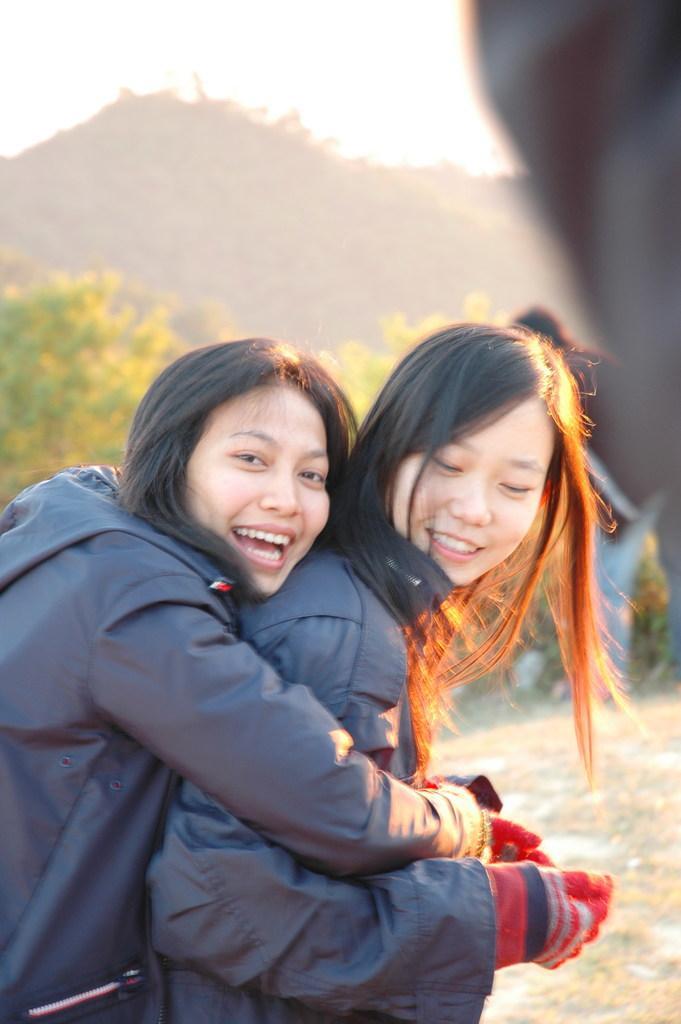How would you summarize this image in a sentence or two? In this image there is the sky, there are mountains, there are plants, there are persons standing, there is an object truncated towards the right of the image, there is a person truncated towards the left of the image, there is a person truncated towards the right of the image. 